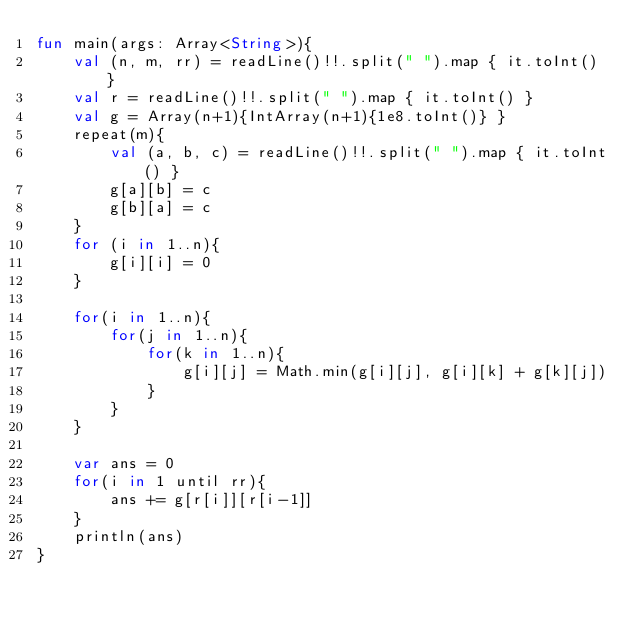Convert code to text. <code><loc_0><loc_0><loc_500><loc_500><_Kotlin_>fun main(args: Array<String>){
    val (n, m, rr) = readLine()!!.split(" ").map { it.toInt() }
    val r = readLine()!!.split(" ").map { it.toInt() }
    val g = Array(n+1){IntArray(n+1){1e8.toInt()} }
    repeat(m){
        val (a, b, c) = readLine()!!.split(" ").map { it.toInt() }
        g[a][b] = c
        g[b][a] = c
    }
    for (i in 1..n){
        g[i][i] = 0
    }

    for(i in 1..n){
        for(j in 1..n){
            for(k in 1..n){
                g[i][j] = Math.min(g[i][j], g[i][k] + g[k][j])
            }
        }
    }

    var ans = 0
    for(i in 1 until rr){
        ans += g[r[i]][r[i-1]]
    }
    println(ans)
}</code> 